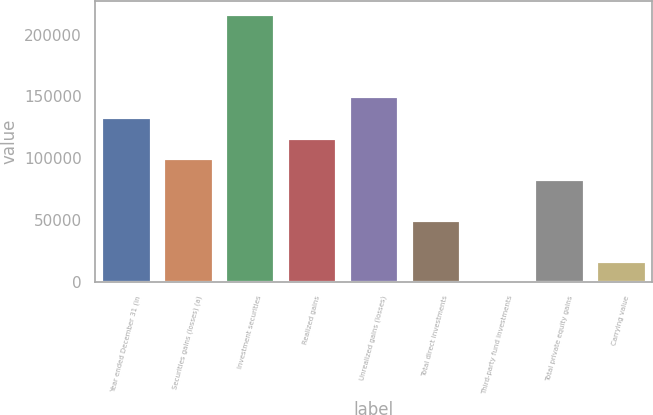Convert chart. <chart><loc_0><loc_0><loc_500><loc_500><bar_chart><fcel>Year ended December 31 (in<fcel>Securities gains (losses) (a)<fcel>Investment securities<fcel>Realized gains<fcel>Unrealized gains (losses)<fcel>Total direct investments<fcel>Third-party fund investments<fcel>Total private equity gains<fcel>Carrying value<nl><fcel>133356<fcel>100050<fcel>216621<fcel>116703<fcel>150009<fcel>50090.3<fcel>131<fcel>83396.5<fcel>16784.1<nl></chart> 